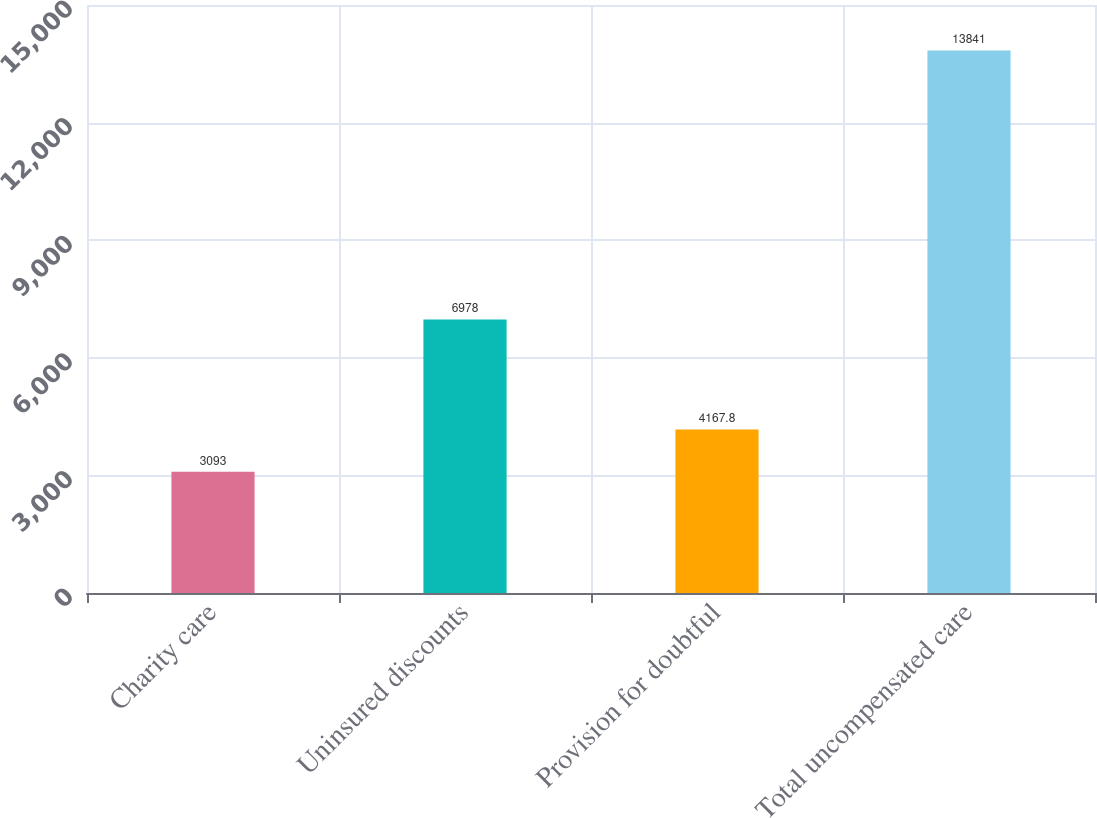Convert chart. <chart><loc_0><loc_0><loc_500><loc_500><bar_chart><fcel>Charity care<fcel>Uninsured discounts<fcel>Provision for doubtful<fcel>Total uncompensated care<nl><fcel>3093<fcel>6978<fcel>4167.8<fcel>13841<nl></chart> 